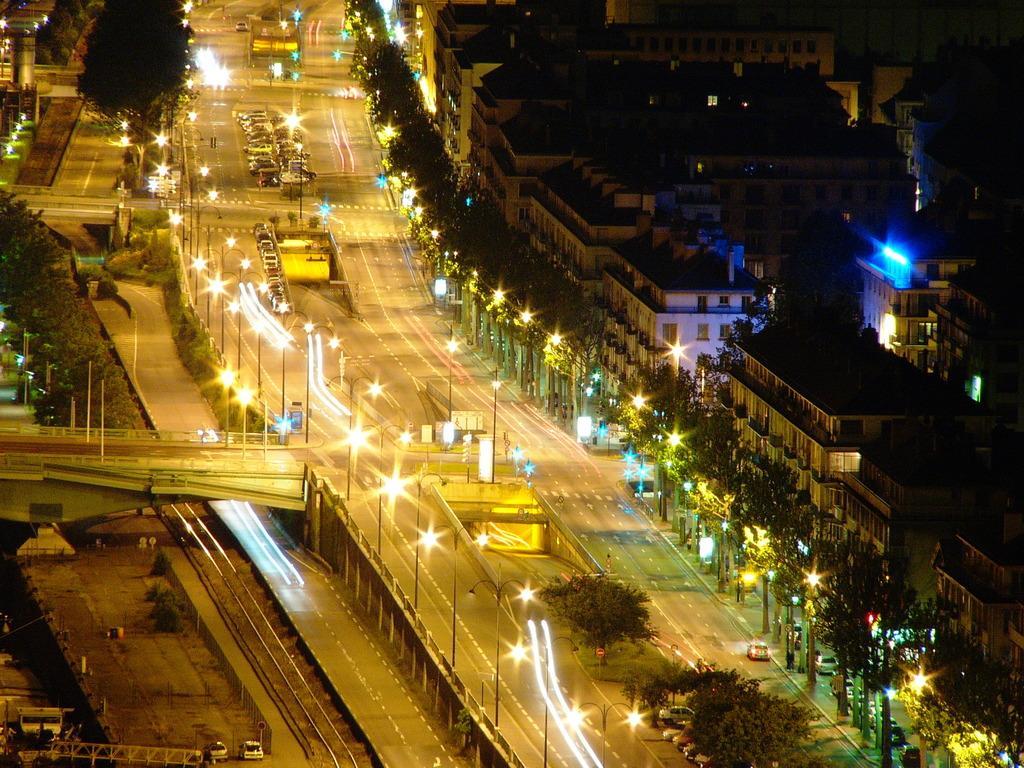Please provide a concise description of this image. In this image, there is an outside view. There is a road in between street poles. There are some buildings on the right side of the image. There is trees at the bottom of the image. There is a bridge on the left side of the image. 